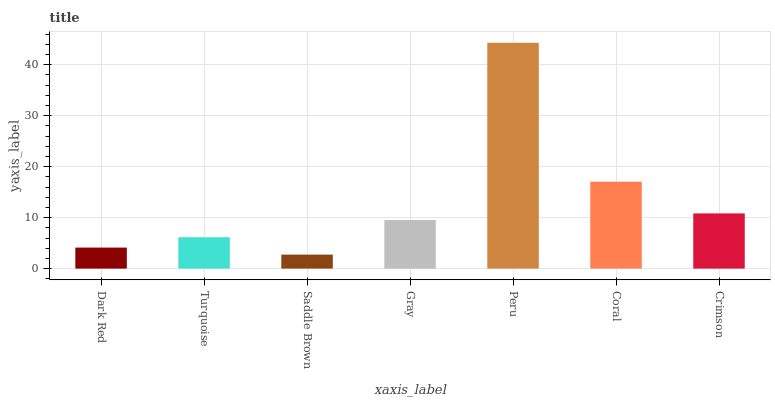Is Saddle Brown the minimum?
Answer yes or no. Yes. Is Peru the maximum?
Answer yes or no. Yes. Is Turquoise the minimum?
Answer yes or no. No. Is Turquoise the maximum?
Answer yes or no. No. Is Turquoise greater than Dark Red?
Answer yes or no. Yes. Is Dark Red less than Turquoise?
Answer yes or no. Yes. Is Dark Red greater than Turquoise?
Answer yes or no. No. Is Turquoise less than Dark Red?
Answer yes or no. No. Is Gray the high median?
Answer yes or no. Yes. Is Gray the low median?
Answer yes or no. Yes. Is Crimson the high median?
Answer yes or no. No. Is Dark Red the low median?
Answer yes or no. No. 